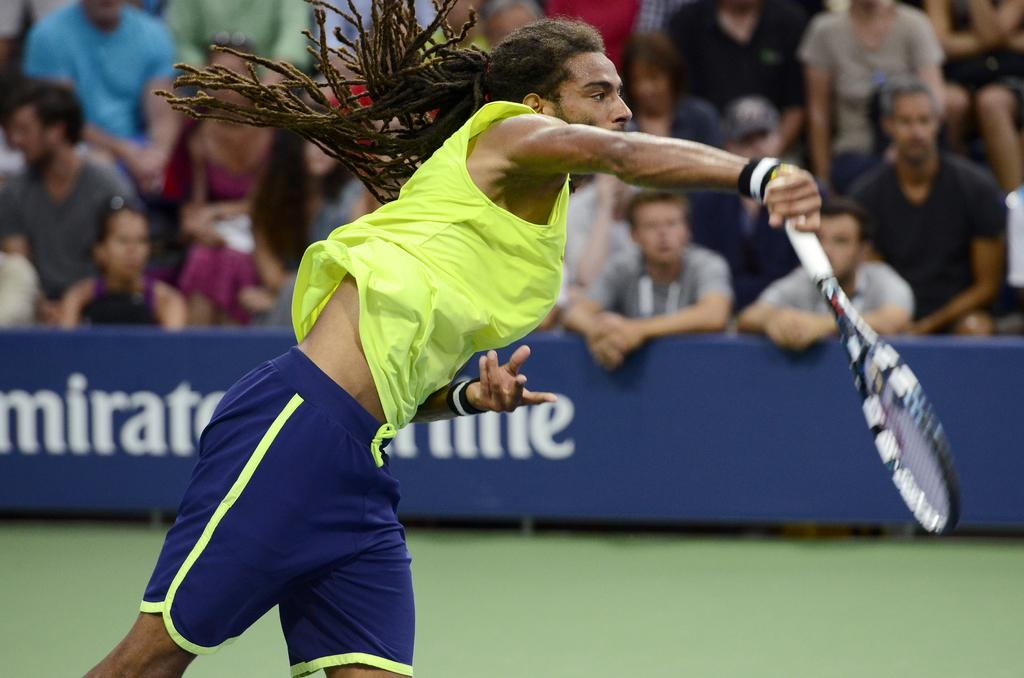What activity is the man in the image engaged in? The man is playing tennis in the image. Are there any other people present in the image besides the man playing tennis? Yes, there is an audience in the image. What can be seen on the side of the tennis court? There is a hoarding in the image. What type of milk is being served to the pet in the image? There is no pet or milk present in the image; it features a man playing tennis with an audience watching. 